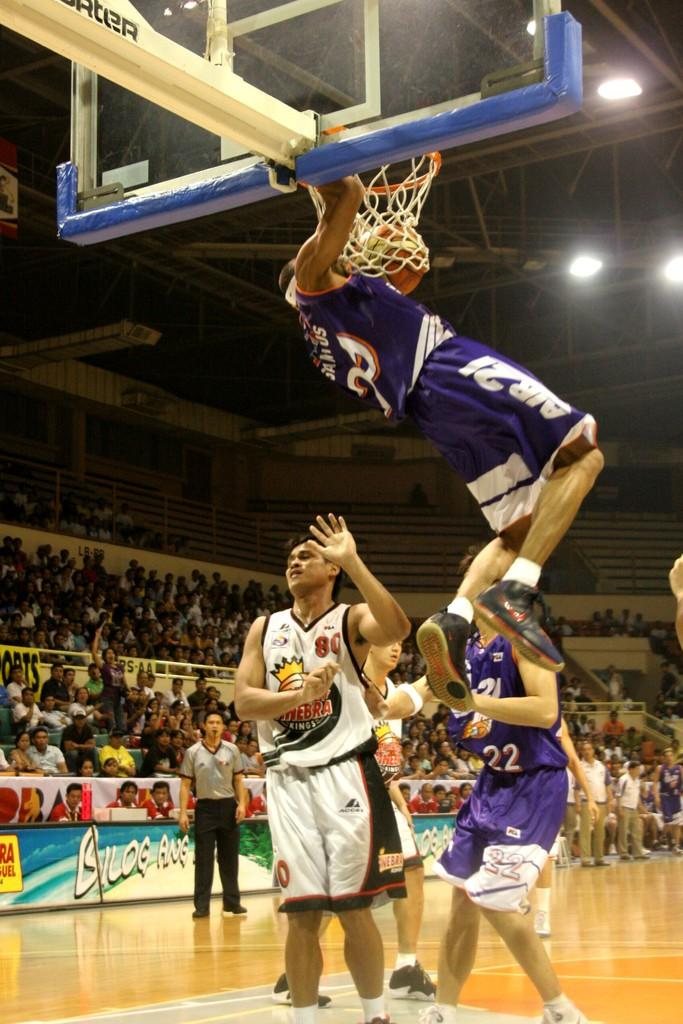<image>
Summarize the visual content of the image. a player with the number 22 sitting below the basket 